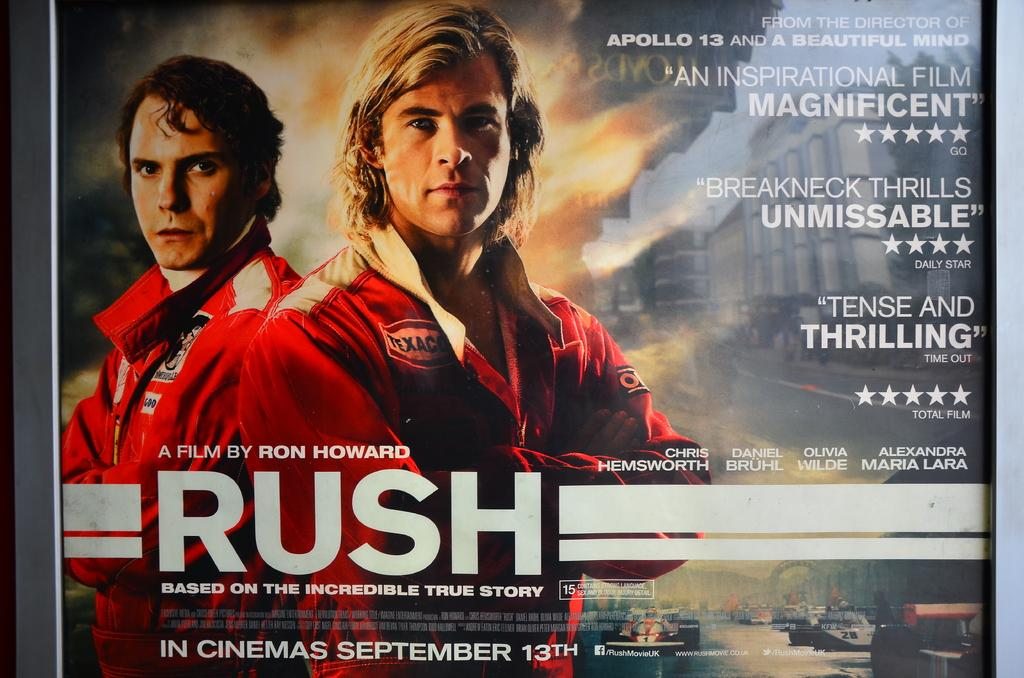<image>
Describe the image concisely. The movie poster advertises Ron Howard's new film, Rush 